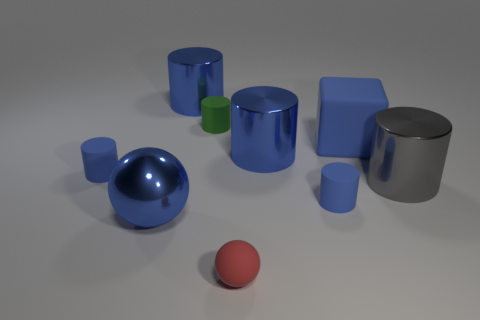Is the number of blue spheres behind the tiny green matte cylinder greater than the number of green matte cylinders that are behind the gray cylinder?
Provide a succinct answer. No. What number of spheres are blue objects or small green things?
Your answer should be compact. 1. What number of big blue things are to the left of the small blue rubber object that is on the right side of the small blue cylinder that is left of the small red sphere?
Keep it short and to the point. 3. There is a big ball that is the same color as the big rubber cube; what material is it?
Your response must be concise. Metal. Is the number of big brown metallic spheres greater than the number of things?
Your answer should be very brief. No. Do the gray cylinder and the rubber sphere have the same size?
Keep it short and to the point. No. What number of things are blue shiny cylinders or large blue balls?
Your response must be concise. 3. What is the shape of the red thing that is left of the large shiny cylinder that is in front of the blue matte cylinder behind the large gray metal cylinder?
Offer a very short reply. Sphere. Do the ball that is in front of the large blue sphere and the tiny blue thing that is right of the green thing have the same material?
Your response must be concise. Yes. There is a big gray thing that is the same shape as the tiny green matte object; what material is it?
Ensure brevity in your answer.  Metal. 